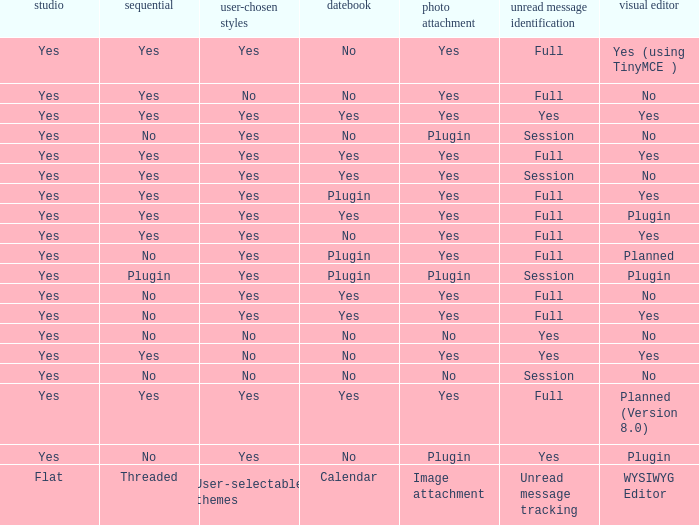Which Calendar has a WYSIWYG Editor of no, and an Unread message tracking of session, and an Image attachment of no? No. 